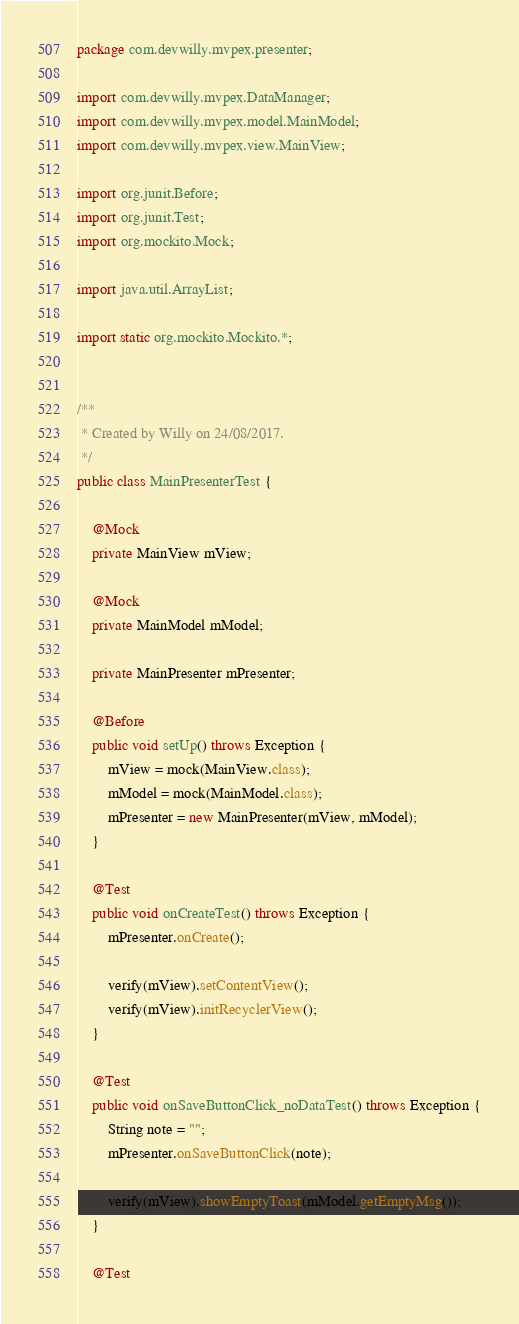<code> <loc_0><loc_0><loc_500><loc_500><_Java_>package com.devwilly.mvpex.presenter;

import com.devwilly.mvpex.DataManager;
import com.devwilly.mvpex.model.MainModel;
import com.devwilly.mvpex.view.MainView;

import org.junit.Before;
import org.junit.Test;
import org.mockito.Mock;

import java.util.ArrayList;

import static org.mockito.Mockito.*;


/**
 * Created by Willy on 24/08/2017.
 */
public class MainPresenterTest {

    @Mock
    private MainView mView;

    @Mock
    private MainModel mModel;

    private MainPresenter mPresenter;

    @Before
    public void setUp() throws Exception {
        mView = mock(MainView.class);
        mModel = mock(MainModel.class);
        mPresenter = new MainPresenter(mView, mModel);
    }

    @Test
    public void onCreateTest() throws Exception {
        mPresenter.onCreate();

        verify(mView).setContentView();
        verify(mView).initRecyclerView();
    }

    @Test
    public void onSaveButtonClick_noDataTest() throws Exception {
        String note = "";
        mPresenter.onSaveButtonClick(note);

        verify(mView).showEmptyToast(mModel.getEmptyMsg());
    }

    @Test</code> 